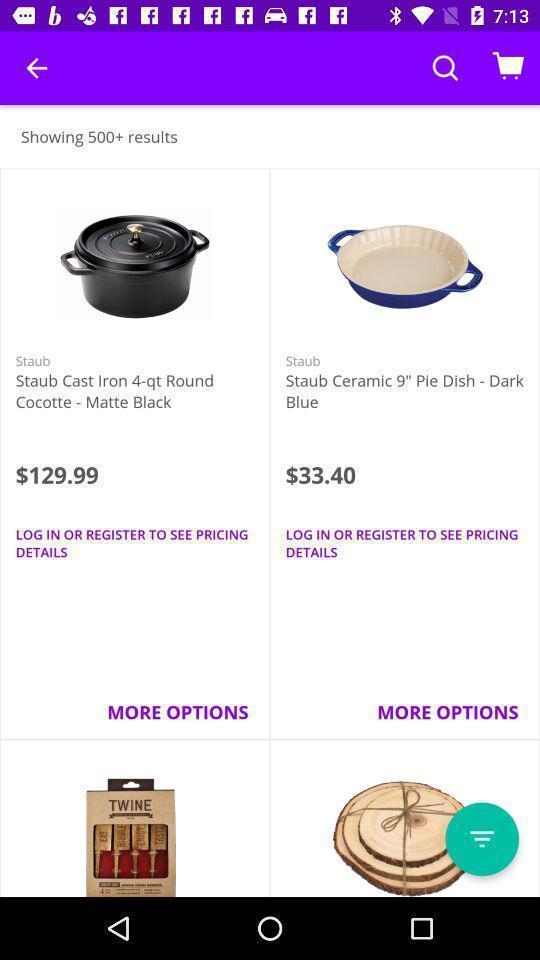Please provide a description for this image. Page of an online shopping application. 